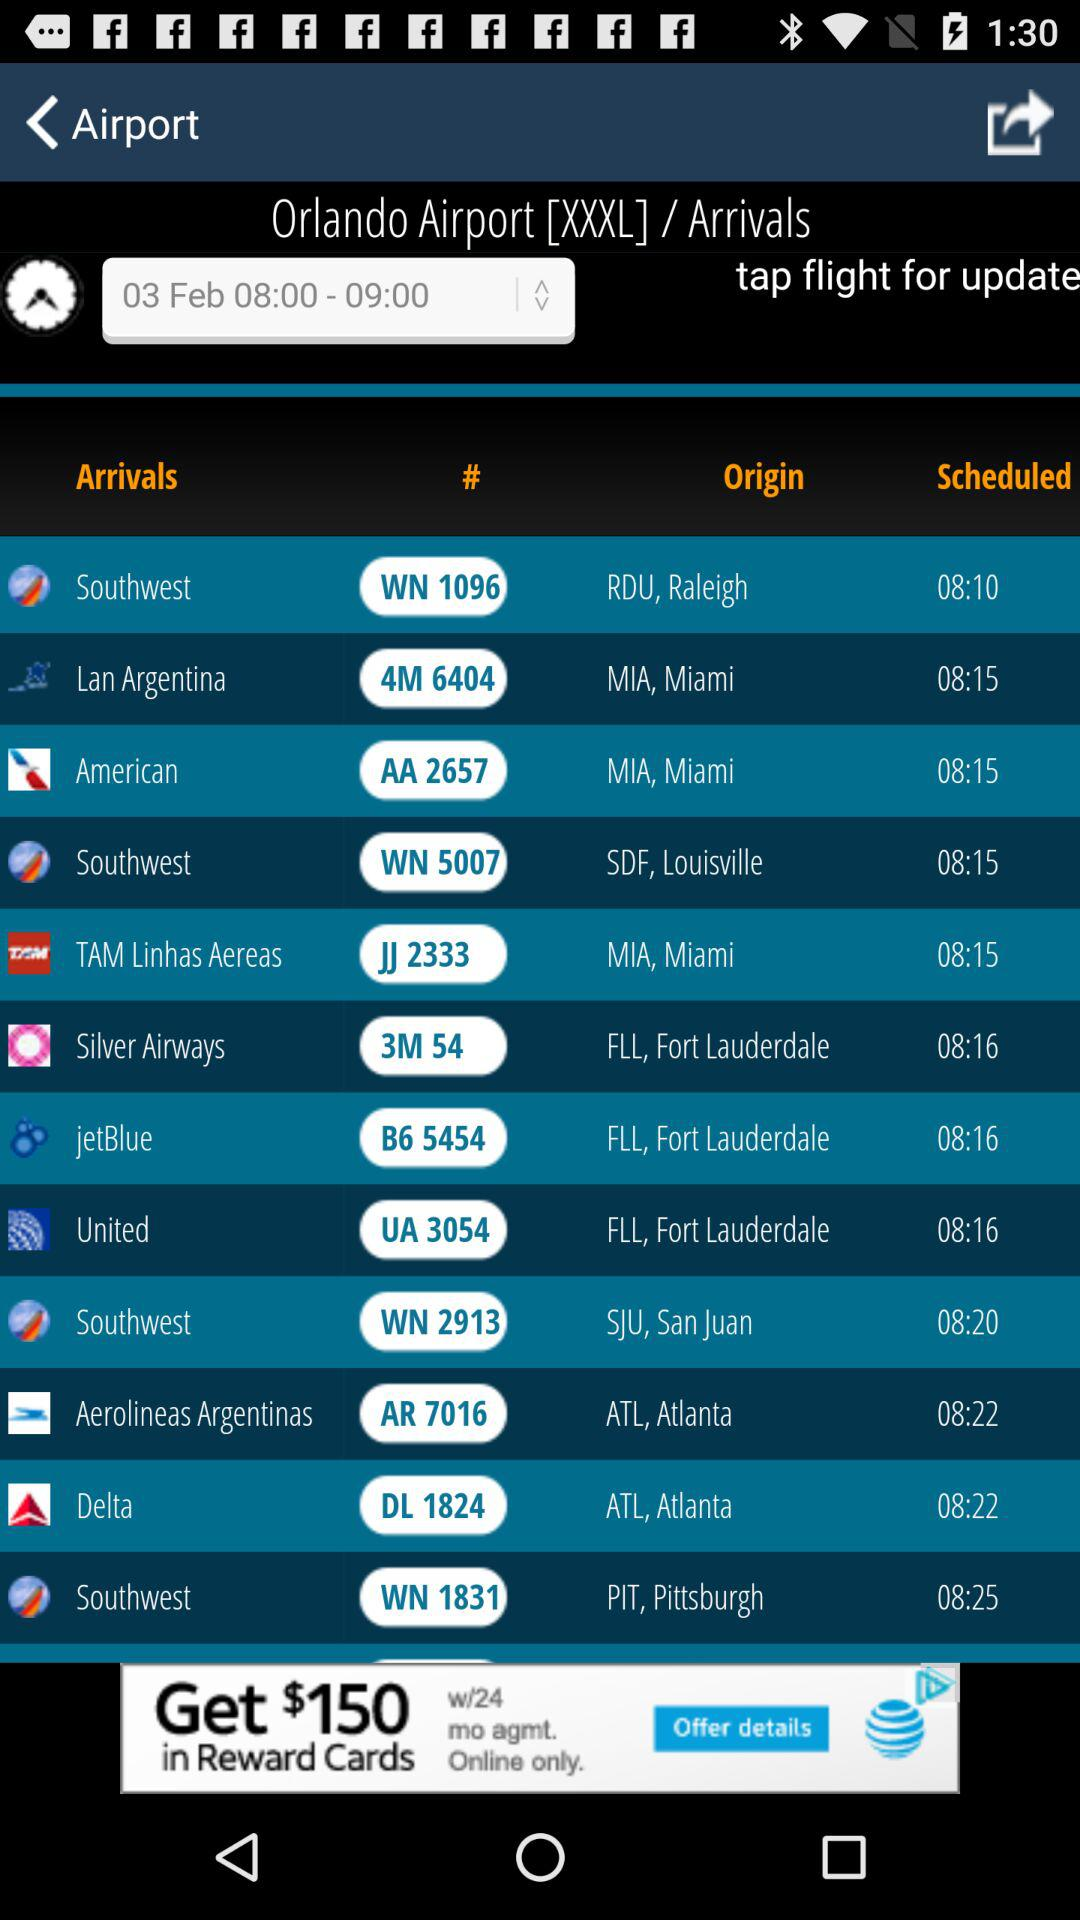What is the time for "Silver Airways" arrivals? The time is 08:16. 